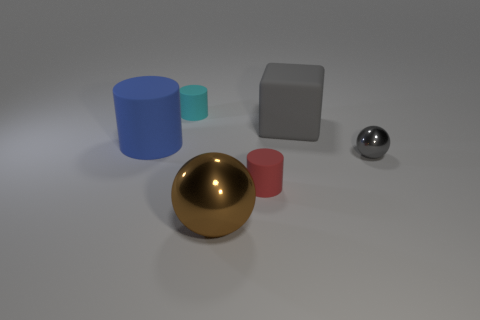Add 3 red matte cylinders. How many objects exist? 9 Subtract all balls. How many objects are left? 4 Add 5 large brown shiny spheres. How many large brown shiny spheres exist? 6 Subtract 0 green balls. How many objects are left? 6 Subtract all big green matte cylinders. Subtract all tiny objects. How many objects are left? 3 Add 4 large blue rubber cylinders. How many large blue rubber cylinders are left? 5 